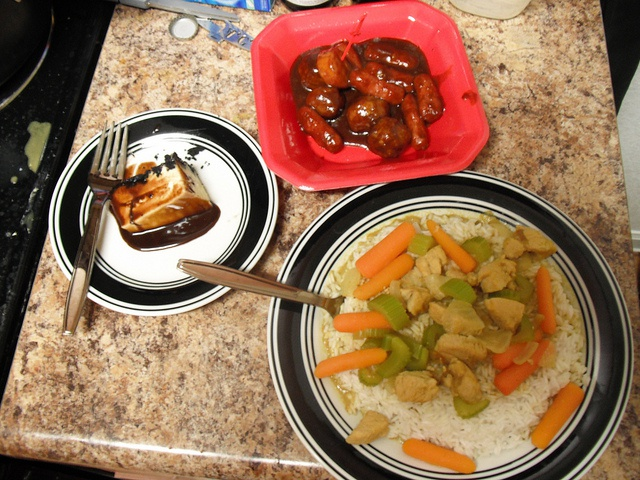Describe the objects in this image and their specific colors. I can see dining table in black, tan, and olive tones, bowl in black, salmon, red, brown, and maroon tones, cake in black, brown, tan, maroon, and orange tones, fork in black, maroon, tan, and gray tones, and carrot in black, brown, maroon, and tan tones in this image. 